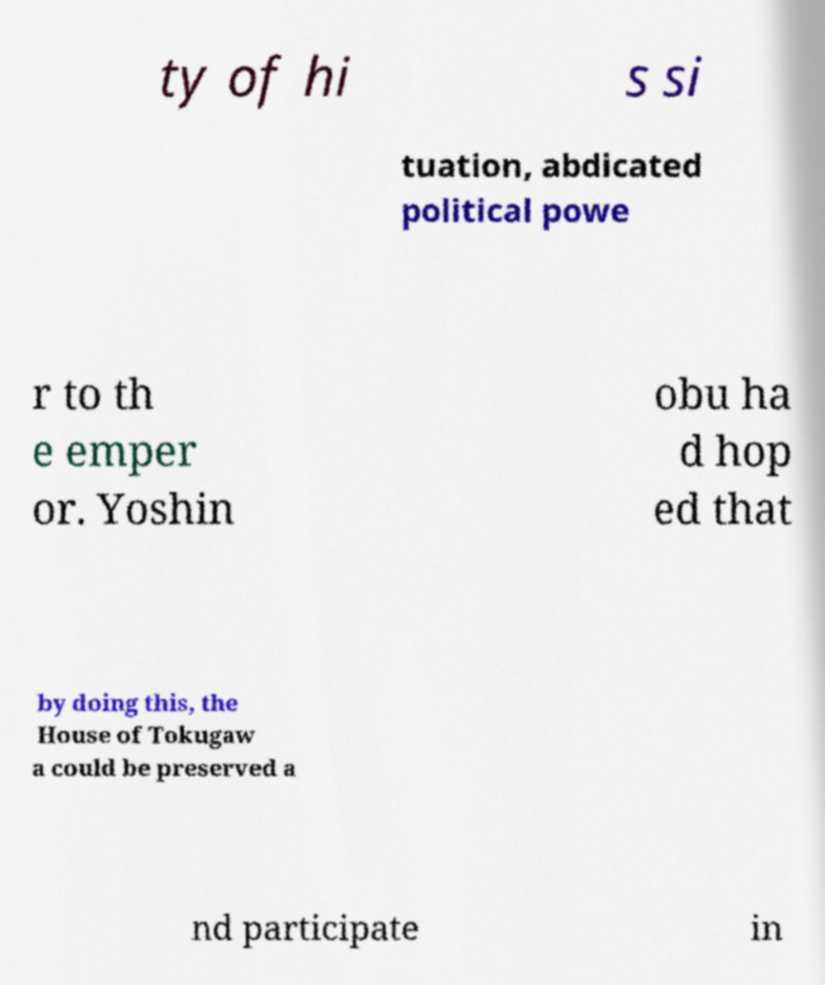Can you accurately transcribe the text from the provided image for me? ty of hi s si tuation, abdicated political powe r to th e emper or. Yoshin obu ha d hop ed that by doing this, the House of Tokugaw a could be preserved a nd participate in 